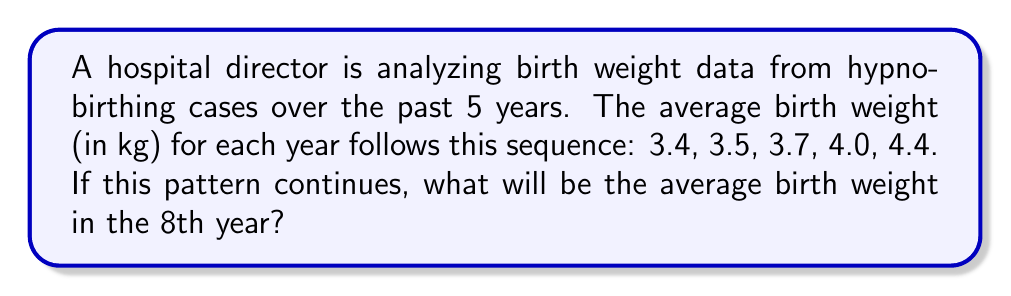Teach me how to tackle this problem. To solve this problem, we need to identify the pattern in the given sequence and extend it to the 8th year. Let's analyze the differences between consecutive terms:

1. First, calculate the differences between consecutive terms:
   $3.5 - 3.4 = 0.1$
   $3.7 - 3.5 = 0.2$
   $4.0 - 3.7 = 0.3$
   $4.4 - 4.0 = 0.4$

2. We can see that the differences are increasing by 0.1 each time:
   $0.1, 0.2, 0.3, 0.4$

3. This suggests that the sequence follows a quadratic pattern.

4. To find the next terms, we continue the pattern of differences:
   5th to 6th year: $4.4 + 0.5 = 4.9$
   6th to 7th year: $4.9 + 0.6 = 5.5$
   7th to 8th year: $5.5 + 0.7 = 6.2$

5. Therefore, the average birth weight in the 8th year will be 6.2 kg.

To verify, we can check if the sequence fits a quadratic formula:
$a_n = an^2 + bn + c$, where $n$ is the term number (1 to 8).

Using the first three terms, we can solve for $a$, $b$, and $c$:
$3.4 = a(1)^2 + b(1) + c$
$3.5 = a(2)^2 + b(2) + c$
$3.7 = a(3)^2 + b(3) + c$

Solving this system of equations gives us:
$a_n = 0.05n^2 + 0.05n + 3.3$

Plugging in $n = 8$:
$a_8 = 0.05(8)^2 + 0.05(8) + 3.3 = 6.2$

This confirms our result.
Answer: 6.2 kg 